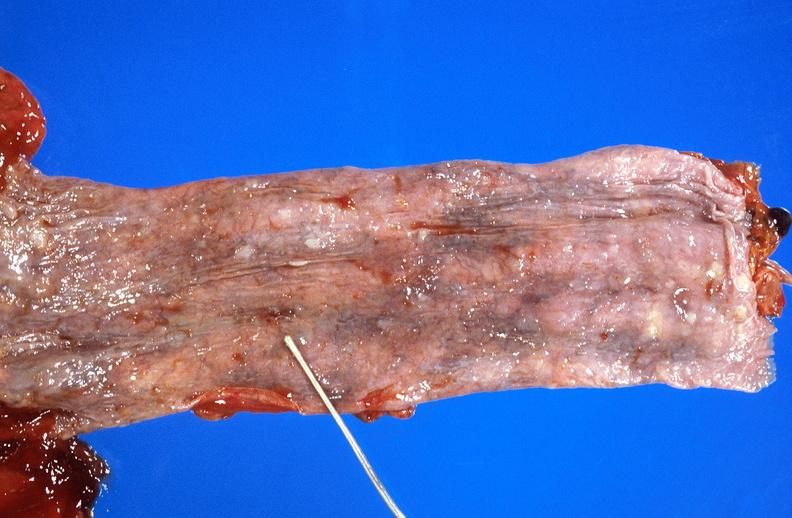s all the fat necrosis present?
Answer the question using a single word or phrase. No 